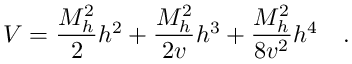<formula> <loc_0><loc_0><loc_500><loc_500>V = { \frac { M _ { h } ^ { 2 } } { 2 } } h ^ { 2 } + { \frac { M _ { h } ^ { 2 } } { 2 v } } h ^ { 3 } + { \frac { M _ { h } ^ { 2 } } { 8 v ^ { 2 } } } h ^ { 4 } \quad .</formula> 